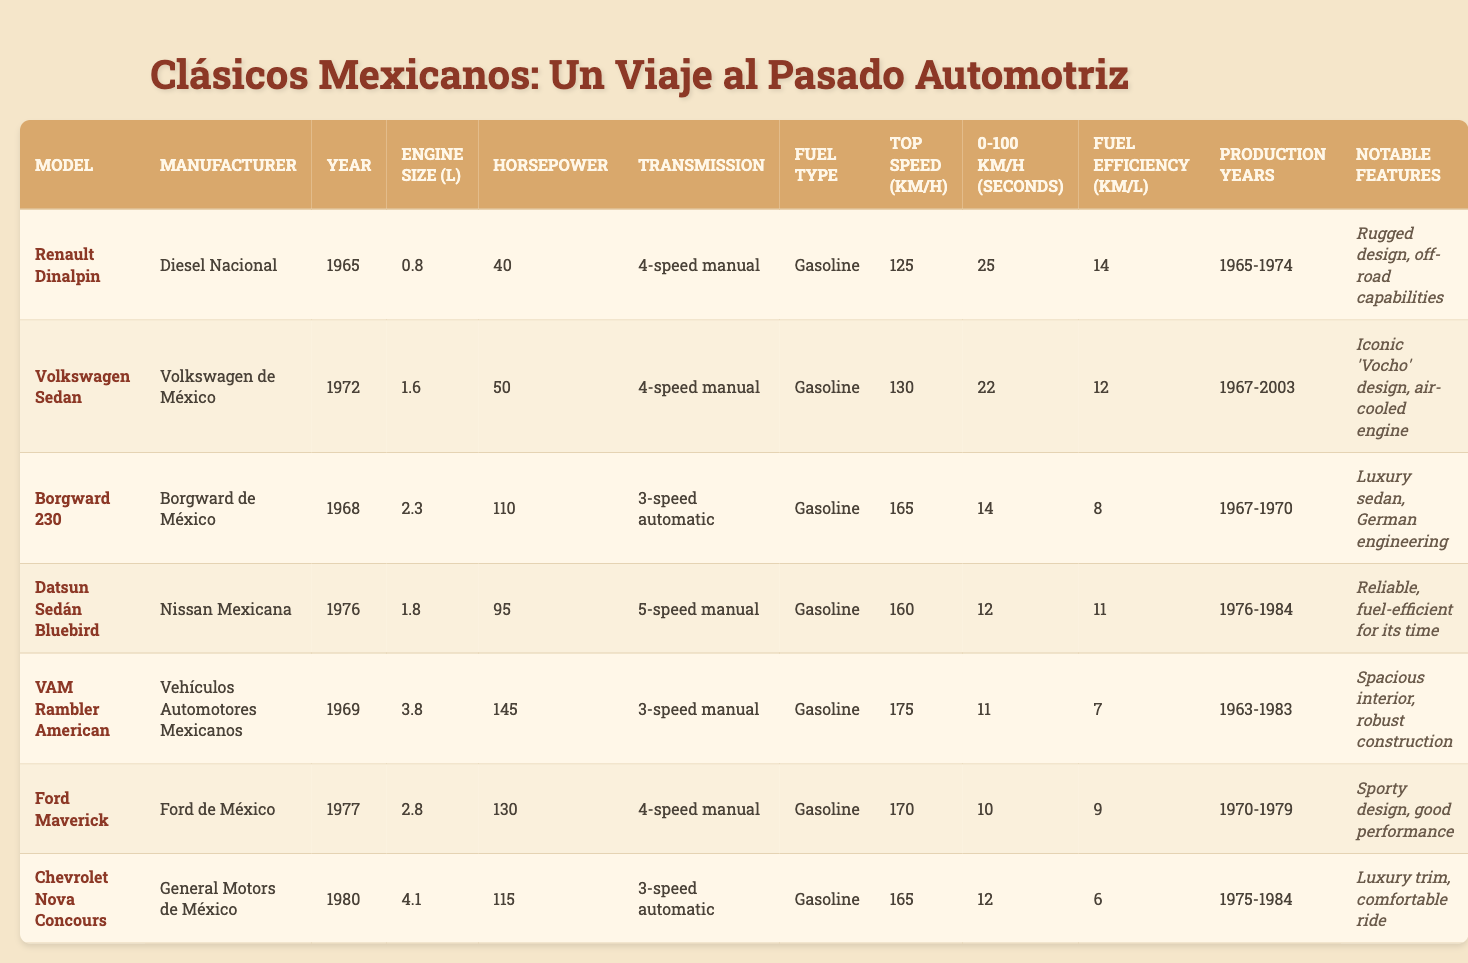What is the engine size of the Ford Maverick? The table lists the engine size under the column "Engine Size (L)" for each model. For the Ford Maverick, the engine size is 2.8 liters.
Answer: 2.8 L Which vehicle has the highest horsepower? To find the vehicle with the highest horsepower, we can review the "Horsepower" column. The VAM Rambler American has the highest horsepower at 145.
Answer: 145 HP What is the production year range for the Volkswagen Sedan? The production years for each model are listed in the "Production Years" column. For the Volkswagen Sedan, it spans from 1967 to 2003.
Answer: 1967-2003 Is the Datsun Sedán Bluebird more fuel-efficient than the Ford Maverick? We can compare the "Fuel Efficiency (km/L)" values from both models. The Datsun Sedán Bluebird has 11 km/L, while the Ford Maverick has 9 km/L. Therefore, the Datsun is more fuel-efficient.
Answer: Yes What is the top speed of the Borgward 230? The top speed can be found in the "Top Speed (km/h)" column of the table. The Borgward 230 has a top speed of 165 km/h.
Answer: 165 km/h How many models have a 0-100 km/h time of less than 12 seconds? We need to examine the "0-100 km/h (seconds)" column for all models. The Datsun Sedán Bluebird (12s), VAM Rambler American (11s), and Ford Maverick (10s) all meet the criteria. That totals three models.
Answer: 3 What is the average horsepower of the cars listed? First, we sum the horsepower of all models: 40 (Renault) + 50 (Volkswagen) + 110 (Borgward) + 95 (Datsun) + 145 (VAM) + 130 (Ford) + 115 (Chevrolet) = 785. There are 7 models, so the average is 785/7 = 112.14.
Answer: 112.14 HP Which car model has both the highest top speed and the lowest fuel efficiency? We need to look for the highest "Top Speed (km/h)" and lowest "Fuel Efficiency (km/L)". The VAM Rambler American has a top speed of 175 km/h and a fuel efficiency of 7 km/L, which fits these criteria.
Answer: VAM Rambler American Is the Renault Dinalpin less powerful than the Ford Maverick? The horsepower of the Renault Dinalpin is 40, while the Ford Maverick has 130. Since 40 is less than 130, the answer is yes.
Answer: Yes What notable feature distinguishes the Volkswagen Sedan? The "Notable Features" column mentions that the Volkswagen Sedan is recognized for its "Iconic 'Vocho' design" and an "air-cooled engine".
Answer: Iconic 'Vocho' design, air-cooled engine 